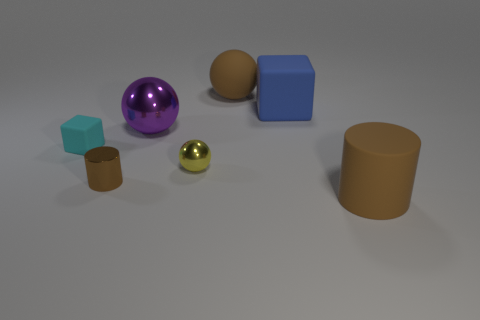Add 3 brown shiny cylinders. How many objects exist? 10 Subtract all spheres. How many objects are left? 4 Add 6 small cyan cubes. How many small cyan cubes exist? 7 Subtract 0 green spheres. How many objects are left? 7 Subtract all large brown spheres. Subtract all matte cylinders. How many objects are left? 5 Add 6 tiny rubber blocks. How many tiny rubber blocks are left? 7 